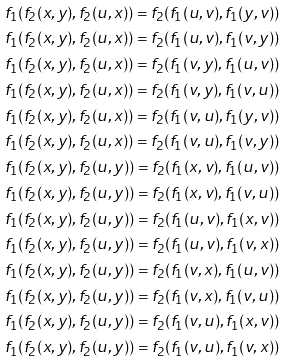Convert formula to latex. <formula><loc_0><loc_0><loc_500><loc_500>f _ { 1 } ( f _ { 2 } ( x , y ) , f _ { 2 } ( u , x ) ) = f _ { 2 } ( f _ { 1 } ( u , v ) , f _ { 1 } ( y , v ) ) \\ f _ { 1 } ( f _ { 2 } ( x , y ) , f _ { 2 } ( u , x ) ) = f _ { 2 } ( f _ { 1 } ( u , v ) , f _ { 1 } ( v , y ) ) \\ f _ { 1 } ( f _ { 2 } ( x , y ) , f _ { 2 } ( u , x ) ) = f _ { 2 } ( f _ { 1 } ( v , y ) , f _ { 1 } ( u , v ) ) \\ f _ { 1 } ( f _ { 2 } ( x , y ) , f _ { 2 } ( u , x ) ) = f _ { 2 } ( f _ { 1 } ( v , y ) , f _ { 1 } ( v , u ) ) \\ f _ { 1 } ( f _ { 2 } ( x , y ) , f _ { 2 } ( u , x ) ) = f _ { 2 } ( f _ { 1 } ( v , u ) , f _ { 1 } ( y , v ) ) \\ f _ { 1 } ( f _ { 2 } ( x , y ) , f _ { 2 } ( u , x ) ) = f _ { 2 } ( f _ { 1 } ( v , u ) , f _ { 1 } ( v , y ) ) \\ f _ { 1 } ( f _ { 2 } ( x , y ) , f _ { 2 } ( u , y ) ) = f _ { 2 } ( f _ { 1 } ( x , v ) , f _ { 1 } ( u , v ) ) \\ f _ { 1 } ( f _ { 2 } ( x , y ) , f _ { 2 } ( u , y ) ) = f _ { 2 } ( f _ { 1 } ( x , v ) , f _ { 1 } ( v , u ) ) \\ f _ { 1 } ( f _ { 2 } ( x , y ) , f _ { 2 } ( u , y ) ) = f _ { 2 } ( f _ { 1 } ( u , v ) , f _ { 1 } ( x , v ) ) \\ f _ { 1 } ( f _ { 2 } ( x , y ) , f _ { 2 } ( u , y ) ) = f _ { 2 } ( f _ { 1 } ( u , v ) , f _ { 1 } ( v , x ) ) \\ f _ { 1 } ( f _ { 2 } ( x , y ) , f _ { 2 } ( u , y ) ) = f _ { 2 } ( f _ { 1 } ( v , x ) , f _ { 1 } ( u , v ) ) \\ f _ { 1 } ( f _ { 2 } ( x , y ) , f _ { 2 } ( u , y ) ) = f _ { 2 } ( f _ { 1 } ( v , x ) , f _ { 1 } ( v , u ) ) \\ f _ { 1 } ( f _ { 2 } ( x , y ) , f _ { 2 } ( u , y ) ) = f _ { 2 } ( f _ { 1 } ( v , u ) , f _ { 1 } ( x , v ) ) \\ f _ { 1 } ( f _ { 2 } ( x , y ) , f _ { 2 } ( u , y ) ) = f _ { 2 } ( f _ { 1 } ( v , u ) , f _ { 1 } ( v , x ) )</formula> 